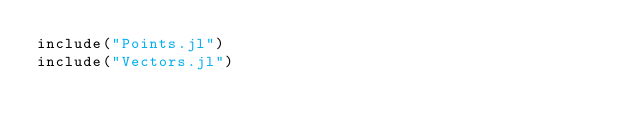<code> <loc_0><loc_0><loc_500><loc_500><_Julia_>include("Points.jl")
include("Vectors.jl")


</code> 